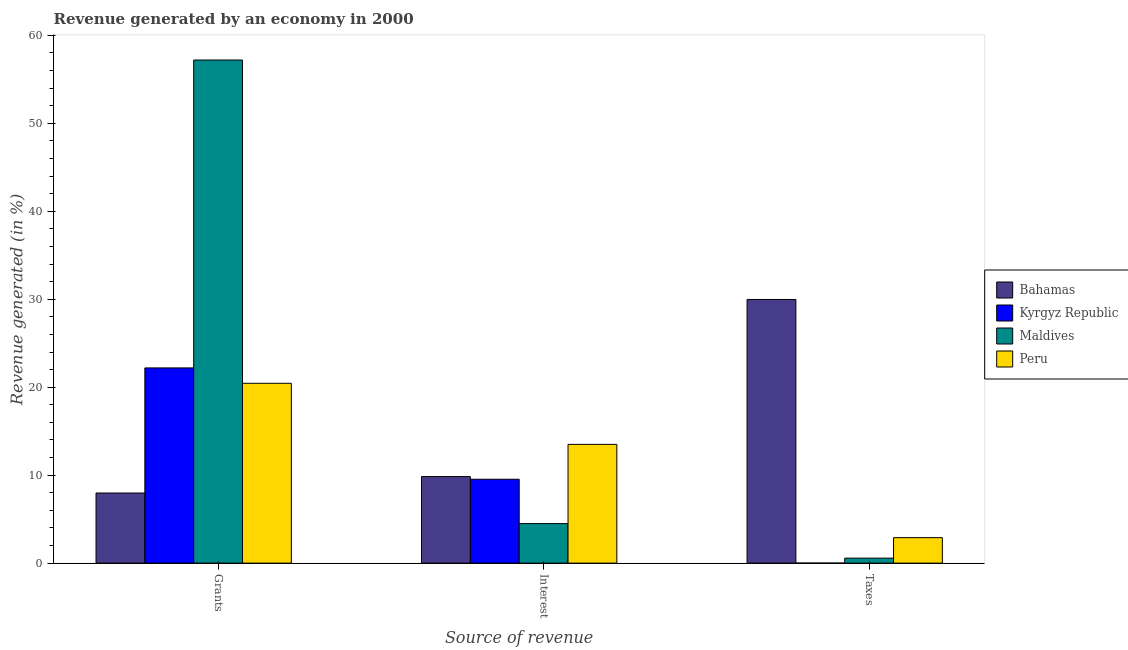How many different coloured bars are there?
Offer a terse response. 4. How many groups of bars are there?
Provide a short and direct response. 3. Are the number of bars per tick equal to the number of legend labels?
Your answer should be compact. Yes. How many bars are there on the 1st tick from the right?
Provide a short and direct response. 4. What is the label of the 2nd group of bars from the left?
Make the answer very short. Interest. What is the percentage of revenue generated by grants in Kyrgyz Republic?
Your response must be concise. 22.19. Across all countries, what is the maximum percentage of revenue generated by taxes?
Your answer should be very brief. 29.97. Across all countries, what is the minimum percentage of revenue generated by grants?
Make the answer very short. 7.97. In which country was the percentage of revenue generated by taxes maximum?
Offer a very short reply. Bahamas. In which country was the percentage of revenue generated by interest minimum?
Your answer should be compact. Maldives. What is the total percentage of revenue generated by grants in the graph?
Provide a succinct answer. 107.8. What is the difference between the percentage of revenue generated by taxes in Maldives and that in Kyrgyz Republic?
Your answer should be compact. 0.56. What is the difference between the percentage of revenue generated by grants in Bahamas and the percentage of revenue generated by taxes in Kyrgyz Republic?
Ensure brevity in your answer.  7.97. What is the average percentage of revenue generated by grants per country?
Your answer should be compact. 26.95. What is the difference between the percentage of revenue generated by interest and percentage of revenue generated by taxes in Bahamas?
Provide a short and direct response. -20.14. In how many countries, is the percentage of revenue generated by taxes greater than 8 %?
Your response must be concise. 1. What is the ratio of the percentage of revenue generated by interest in Kyrgyz Republic to that in Bahamas?
Keep it short and to the point. 0.97. Is the percentage of revenue generated by grants in Peru less than that in Bahamas?
Your response must be concise. No. What is the difference between the highest and the second highest percentage of revenue generated by grants?
Ensure brevity in your answer.  35. What is the difference between the highest and the lowest percentage of revenue generated by taxes?
Give a very brief answer. 29.97. What does the 3rd bar from the left in Interest represents?
Your answer should be compact. Maldives. What does the 3rd bar from the right in Taxes represents?
Ensure brevity in your answer.  Kyrgyz Republic. How many bars are there?
Your response must be concise. 12. Are all the bars in the graph horizontal?
Your answer should be compact. No. What is the difference between two consecutive major ticks on the Y-axis?
Your answer should be very brief. 10. Are the values on the major ticks of Y-axis written in scientific E-notation?
Your answer should be very brief. No. Where does the legend appear in the graph?
Provide a short and direct response. Center right. How are the legend labels stacked?
Keep it short and to the point. Vertical. What is the title of the graph?
Your response must be concise. Revenue generated by an economy in 2000. Does "Botswana" appear as one of the legend labels in the graph?
Make the answer very short. No. What is the label or title of the X-axis?
Provide a succinct answer. Source of revenue. What is the label or title of the Y-axis?
Give a very brief answer. Revenue generated (in %). What is the Revenue generated (in %) in Bahamas in Grants?
Make the answer very short. 7.97. What is the Revenue generated (in %) in Kyrgyz Republic in Grants?
Provide a succinct answer. 22.19. What is the Revenue generated (in %) of Maldives in Grants?
Make the answer very short. 57.2. What is the Revenue generated (in %) of Peru in Grants?
Your answer should be very brief. 20.44. What is the Revenue generated (in %) in Bahamas in Interest?
Your response must be concise. 9.84. What is the Revenue generated (in %) of Kyrgyz Republic in Interest?
Ensure brevity in your answer.  9.54. What is the Revenue generated (in %) in Maldives in Interest?
Offer a very short reply. 4.49. What is the Revenue generated (in %) of Peru in Interest?
Your response must be concise. 13.5. What is the Revenue generated (in %) in Bahamas in Taxes?
Offer a terse response. 29.97. What is the Revenue generated (in %) of Kyrgyz Republic in Taxes?
Offer a very short reply. 0. What is the Revenue generated (in %) in Maldives in Taxes?
Give a very brief answer. 0.57. What is the Revenue generated (in %) of Peru in Taxes?
Offer a terse response. 2.89. Across all Source of revenue, what is the maximum Revenue generated (in %) in Bahamas?
Offer a very short reply. 29.97. Across all Source of revenue, what is the maximum Revenue generated (in %) of Kyrgyz Republic?
Provide a short and direct response. 22.19. Across all Source of revenue, what is the maximum Revenue generated (in %) in Maldives?
Offer a terse response. 57.2. Across all Source of revenue, what is the maximum Revenue generated (in %) in Peru?
Your answer should be compact. 20.44. Across all Source of revenue, what is the minimum Revenue generated (in %) of Bahamas?
Ensure brevity in your answer.  7.97. Across all Source of revenue, what is the minimum Revenue generated (in %) in Kyrgyz Republic?
Provide a succinct answer. 0. Across all Source of revenue, what is the minimum Revenue generated (in %) of Maldives?
Offer a very short reply. 0.57. Across all Source of revenue, what is the minimum Revenue generated (in %) of Peru?
Your answer should be very brief. 2.89. What is the total Revenue generated (in %) of Bahamas in the graph?
Your answer should be compact. 47.78. What is the total Revenue generated (in %) in Kyrgyz Republic in the graph?
Your response must be concise. 31.73. What is the total Revenue generated (in %) of Maldives in the graph?
Offer a very short reply. 62.25. What is the total Revenue generated (in %) of Peru in the graph?
Give a very brief answer. 36.84. What is the difference between the Revenue generated (in %) in Bahamas in Grants and that in Interest?
Offer a terse response. -1.87. What is the difference between the Revenue generated (in %) in Kyrgyz Republic in Grants and that in Interest?
Ensure brevity in your answer.  12.66. What is the difference between the Revenue generated (in %) in Maldives in Grants and that in Interest?
Keep it short and to the point. 52.7. What is the difference between the Revenue generated (in %) in Peru in Grants and that in Interest?
Ensure brevity in your answer.  6.94. What is the difference between the Revenue generated (in %) in Bahamas in Grants and that in Taxes?
Ensure brevity in your answer.  -22. What is the difference between the Revenue generated (in %) of Kyrgyz Republic in Grants and that in Taxes?
Give a very brief answer. 22.19. What is the difference between the Revenue generated (in %) in Maldives in Grants and that in Taxes?
Offer a terse response. 56.63. What is the difference between the Revenue generated (in %) of Peru in Grants and that in Taxes?
Provide a succinct answer. 17.55. What is the difference between the Revenue generated (in %) in Bahamas in Interest and that in Taxes?
Provide a succinct answer. -20.14. What is the difference between the Revenue generated (in %) in Kyrgyz Republic in Interest and that in Taxes?
Provide a succinct answer. 9.53. What is the difference between the Revenue generated (in %) of Maldives in Interest and that in Taxes?
Provide a short and direct response. 3.93. What is the difference between the Revenue generated (in %) of Peru in Interest and that in Taxes?
Your answer should be compact. 10.61. What is the difference between the Revenue generated (in %) of Bahamas in Grants and the Revenue generated (in %) of Kyrgyz Republic in Interest?
Keep it short and to the point. -1.56. What is the difference between the Revenue generated (in %) of Bahamas in Grants and the Revenue generated (in %) of Maldives in Interest?
Your response must be concise. 3.48. What is the difference between the Revenue generated (in %) in Bahamas in Grants and the Revenue generated (in %) in Peru in Interest?
Your answer should be very brief. -5.53. What is the difference between the Revenue generated (in %) of Kyrgyz Republic in Grants and the Revenue generated (in %) of Maldives in Interest?
Your answer should be very brief. 17.7. What is the difference between the Revenue generated (in %) of Kyrgyz Republic in Grants and the Revenue generated (in %) of Peru in Interest?
Offer a very short reply. 8.69. What is the difference between the Revenue generated (in %) of Maldives in Grants and the Revenue generated (in %) of Peru in Interest?
Make the answer very short. 43.7. What is the difference between the Revenue generated (in %) in Bahamas in Grants and the Revenue generated (in %) in Kyrgyz Republic in Taxes?
Offer a very short reply. 7.97. What is the difference between the Revenue generated (in %) in Bahamas in Grants and the Revenue generated (in %) in Maldives in Taxes?
Ensure brevity in your answer.  7.41. What is the difference between the Revenue generated (in %) of Bahamas in Grants and the Revenue generated (in %) of Peru in Taxes?
Your answer should be compact. 5.08. What is the difference between the Revenue generated (in %) in Kyrgyz Republic in Grants and the Revenue generated (in %) in Maldives in Taxes?
Your response must be concise. 21.63. What is the difference between the Revenue generated (in %) in Kyrgyz Republic in Grants and the Revenue generated (in %) in Peru in Taxes?
Provide a short and direct response. 19.3. What is the difference between the Revenue generated (in %) in Maldives in Grants and the Revenue generated (in %) in Peru in Taxes?
Your answer should be very brief. 54.3. What is the difference between the Revenue generated (in %) in Bahamas in Interest and the Revenue generated (in %) in Kyrgyz Republic in Taxes?
Provide a succinct answer. 9.84. What is the difference between the Revenue generated (in %) of Bahamas in Interest and the Revenue generated (in %) of Maldives in Taxes?
Your answer should be compact. 9.27. What is the difference between the Revenue generated (in %) in Bahamas in Interest and the Revenue generated (in %) in Peru in Taxes?
Provide a succinct answer. 6.94. What is the difference between the Revenue generated (in %) in Kyrgyz Republic in Interest and the Revenue generated (in %) in Maldives in Taxes?
Provide a short and direct response. 8.97. What is the difference between the Revenue generated (in %) of Kyrgyz Republic in Interest and the Revenue generated (in %) of Peru in Taxes?
Provide a succinct answer. 6.64. What is the difference between the Revenue generated (in %) of Maldives in Interest and the Revenue generated (in %) of Peru in Taxes?
Ensure brevity in your answer.  1.6. What is the average Revenue generated (in %) in Bahamas per Source of revenue?
Offer a terse response. 15.93. What is the average Revenue generated (in %) in Kyrgyz Republic per Source of revenue?
Keep it short and to the point. 10.58. What is the average Revenue generated (in %) in Maldives per Source of revenue?
Ensure brevity in your answer.  20.75. What is the average Revenue generated (in %) of Peru per Source of revenue?
Your answer should be compact. 12.28. What is the difference between the Revenue generated (in %) of Bahamas and Revenue generated (in %) of Kyrgyz Republic in Grants?
Provide a short and direct response. -14.22. What is the difference between the Revenue generated (in %) of Bahamas and Revenue generated (in %) of Maldives in Grants?
Your answer should be very brief. -49.23. What is the difference between the Revenue generated (in %) of Bahamas and Revenue generated (in %) of Peru in Grants?
Provide a short and direct response. -12.47. What is the difference between the Revenue generated (in %) in Kyrgyz Republic and Revenue generated (in %) in Maldives in Grants?
Offer a very short reply. -35. What is the difference between the Revenue generated (in %) in Kyrgyz Republic and Revenue generated (in %) in Peru in Grants?
Ensure brevity in your answer.  1.75. What is the difference between the Revenue generated (in %) in Maldives and Revenue generated (in %) in Peru in Grants?
Ensure brevity in your answer.  36.75. What is the difference between the Revenue generated (in %) of Bahamas and Revenue generated (in %) of Kyrgyz Republic in Interest?
Ensure brevity in your answer.  0.3. What is the difference between the Revenue generated (in %) in Bahamas and Revenue generated (in %) in Maldives in Interest?
Your answer should be compact. 5.35. What is the difference between the Revenue generated (in %) in Bahamas and Revenue generated (in %) in Peru in Interest?
Ensure brevity in your answer.  -3.66. What is the difference between the Revenue generated (in %) in Kyrgyz Republic and Revenue generated (in %) in Maldives in Interest?
Your answer should be very brief. 5.04. What is the difference between the Revenue generated (in %) in Kyrgyz Republic and Revenue generated (in %) in Peru in Interest?
Your answer should be very brief. -3.97. What is the difference between the Revenue generated (in %) of Maldives and Revenue generated (in %) of Peru in Interest?
Make the answer very short. -9.01. What is the difference between the Revenue generated (in %) in Bahamas and Revenue generated (in %) in Kyrgyz Republic in Taxes?
Your response must be concise. 29.97. What is the difference between the Revenue generated (in %) in Bahamas and Revenue generated (in %) in Maldives in Taxes?
Your answer should be very brief. 29.41. What is the difference between the Revenue generated (in %) in Bahamas and Revenue generated (in %) in Peru in Taxes?
Provide a short and direct response. 27.08. What is the difference between the Revenue generated (in %) of Kyrgyz Republic and Revenue generated (in %) of Maldives in Taxes?
Provide a short and direct response. -0.56. What is the difference between the Revenue generated (in %) of Kyrgyz Republic and Revenue generated (in %) of Peru in Taxes?
Give a very brief answer. -2.89. What is the difference between the Revenue generated (in %) in Maldives and Revenue generated (in %) in Peru in Taxes?
Provide a short and direct response. -2.33. What is the ratio of the Revenue generated (in %) in Bahamas in Grants to that in Interest?
Your answer should be compact. 0.81. What is the ratio of the Revenue generated (in %) of Kyrgyz Republic in Grants to that in Interest?
Ensure brevity in your answer.  2.33. What is the ratio of the Revenue generated (in %) in Maldives in Grants to that in Interest?
Ensure brevity in your answer.  12.73. What is the ratio of the Revenue generated (in %) in Peru in Grants to that in Interest?
Your response must be concise. 1.51. What is the ratio of the Revenue generated (in %) of Bahamas in Grants to that in Taxes?
Provide a short and direct response. 0.27. What is the ratio of the Revenue generated (in %) in Kyrgyz Republic in Grants to that in Taxes?
Offer a very short reply. 1.09e+04. What is the ratio of the Revenue generated (in %) in Maldives in Grants to that in Taxes?
Your response must be concise. 101.1. What is the ratio of the Revenue generated (in %) in Peru in Grants to that in Taxes?
Make the answer very short. 7.06. What is the ratio of the Revenue generated (in %) in Bahamas in Interest to that in Taxes?
Provide a short and direct response. 0.33. What is the ratio of the Revenue generated (in %) in Kyrgyz Republic in Interest to that in Taxes?
Provide a short and direct response. 4703. What is the ratio of the Revenue generated (in %) of Maldives in Interest to that in Taxes?
Offer a terse response. 7.94. What is the ratio of the Revenue generated (in %) of Peru in Interest to that in Taxes?
Give a very brief answer. 4.66. What is the difference between the highest and the second highest Revenue generated (in %) in Bahamas?
Your answer should be very brief. 20.14. What is the difference between the highest and the second highest Revenue generated (in %) of Kyrgyz Republic?
Offer a terse response. 12.66. What is the difference between the highest and the second highest Revenue generated (in %) in Maldives?
Provide a succinct answer. 52.7. What is the difference between the highest and the second highest Revenue generated (in %) of Peru?
Ensure brevity in your answer.  6.94. What is the difference between the highest and the lowest Revenue generated (in %) in Bahamas?
Give a very brief answer. 22. What is the difference between the highest and the lowest Revenue generated (in %) of Kyrgyz Republic?
Provide a succinct answer. 22.19. What is the difference between the highest and the lowest Revenue generated (in %) of Maldives?
Offer a very short reply. 56.63. What is the difference between the highest and the lowest Revenue generated (in %) in Peru?
Your answer should be very brief. 17.55. 